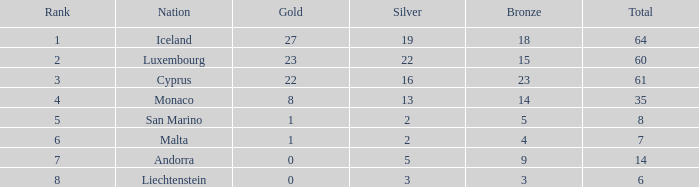How many golds for the state with 14 total? 0.0. 